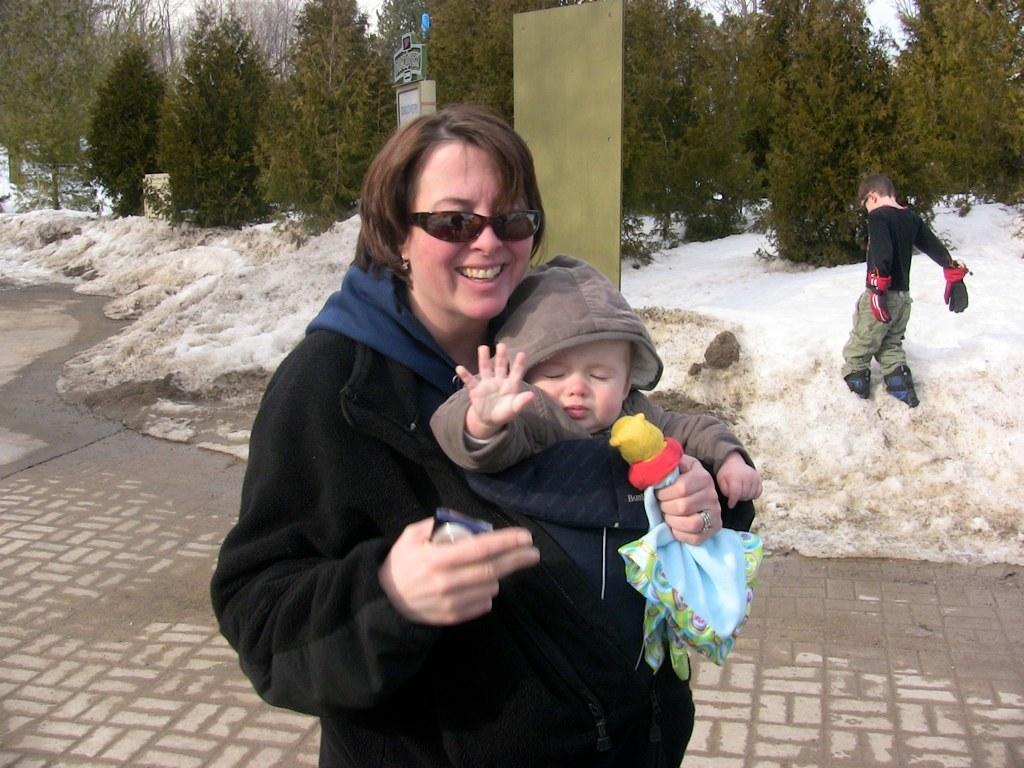What is the person in the image doing with the kid? The person is carrying a kid in the image. What else is the person holding in the image? The person is holding objects. What is the child in the image doing? A child is standing in the water. What can be seen in the background of the image? There are trees and boards in the background of the image. What statement is the pig making in the image? There are no pigs present in the image, so no statement can be attributed to a pig. 